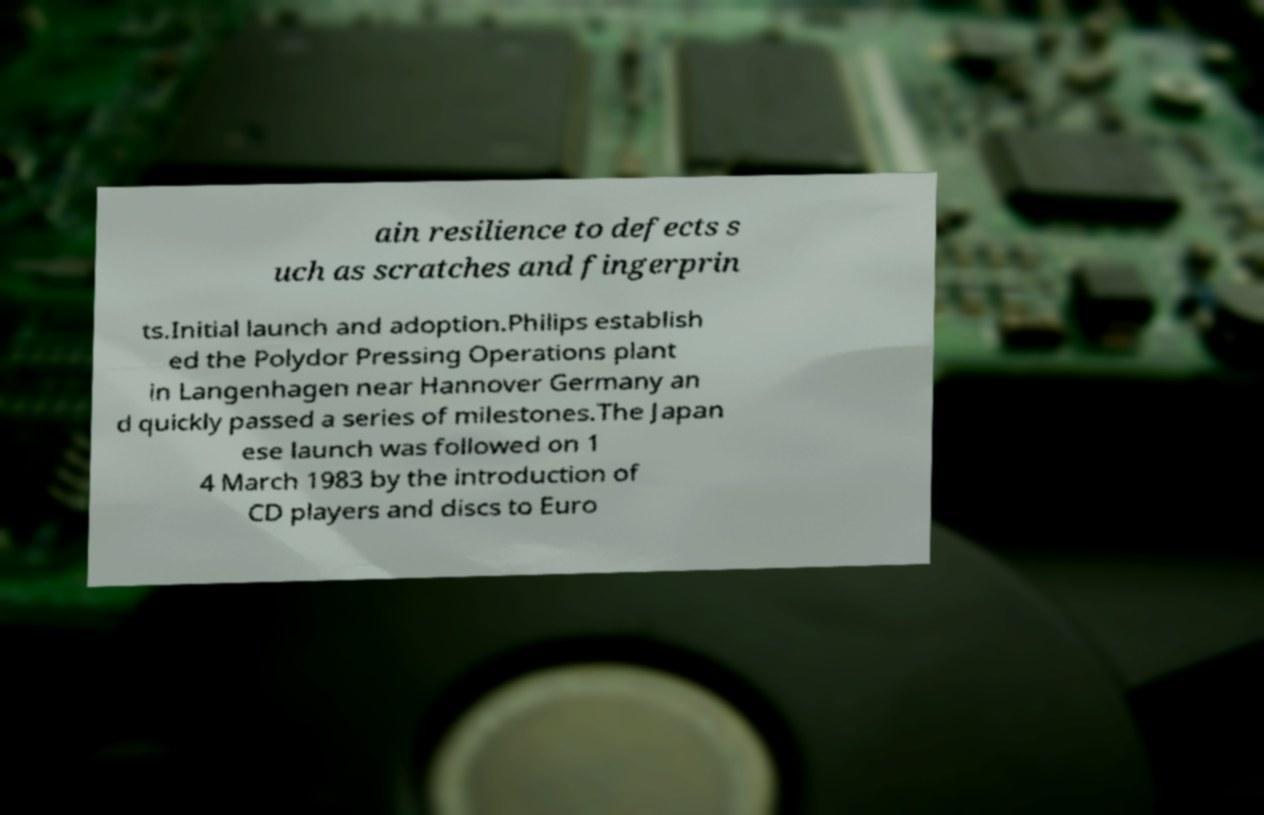Please read and relay the text visible in this image. What does it say? ain resilience to defects s uch as scratches and fingerprin ts.Initial launch and adoption.Philips establish ed the Polydor Pressing Operations plant in Langenhagen near Hannover Germany an d quickly passed a series of milestones.The Japan ese launch was followed on 1 4 March 1983 by the introduction of CD players and discs to Euro 